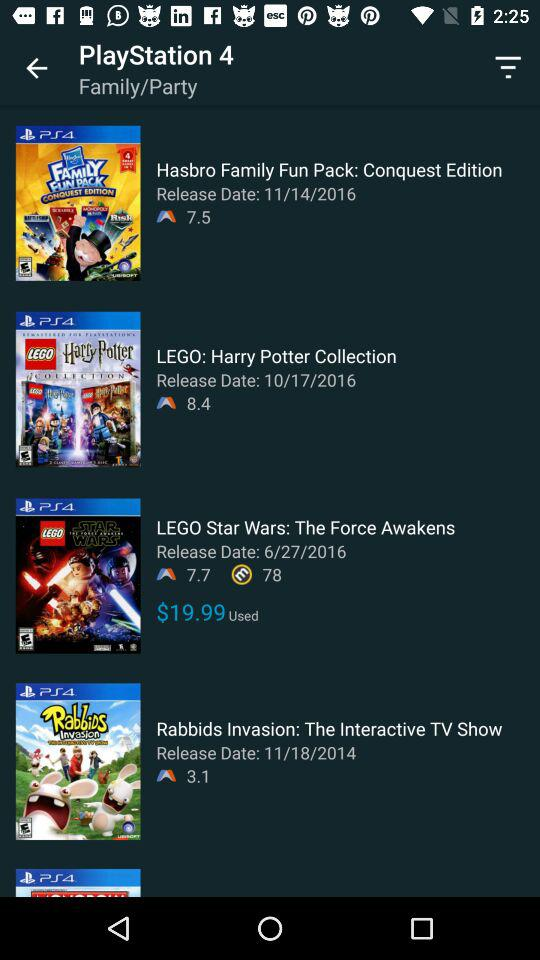What are the ratings for the "Hasbro Family Fun Pack"? The rating for the "Hasbro Family Fun Pack" is 7.5. 